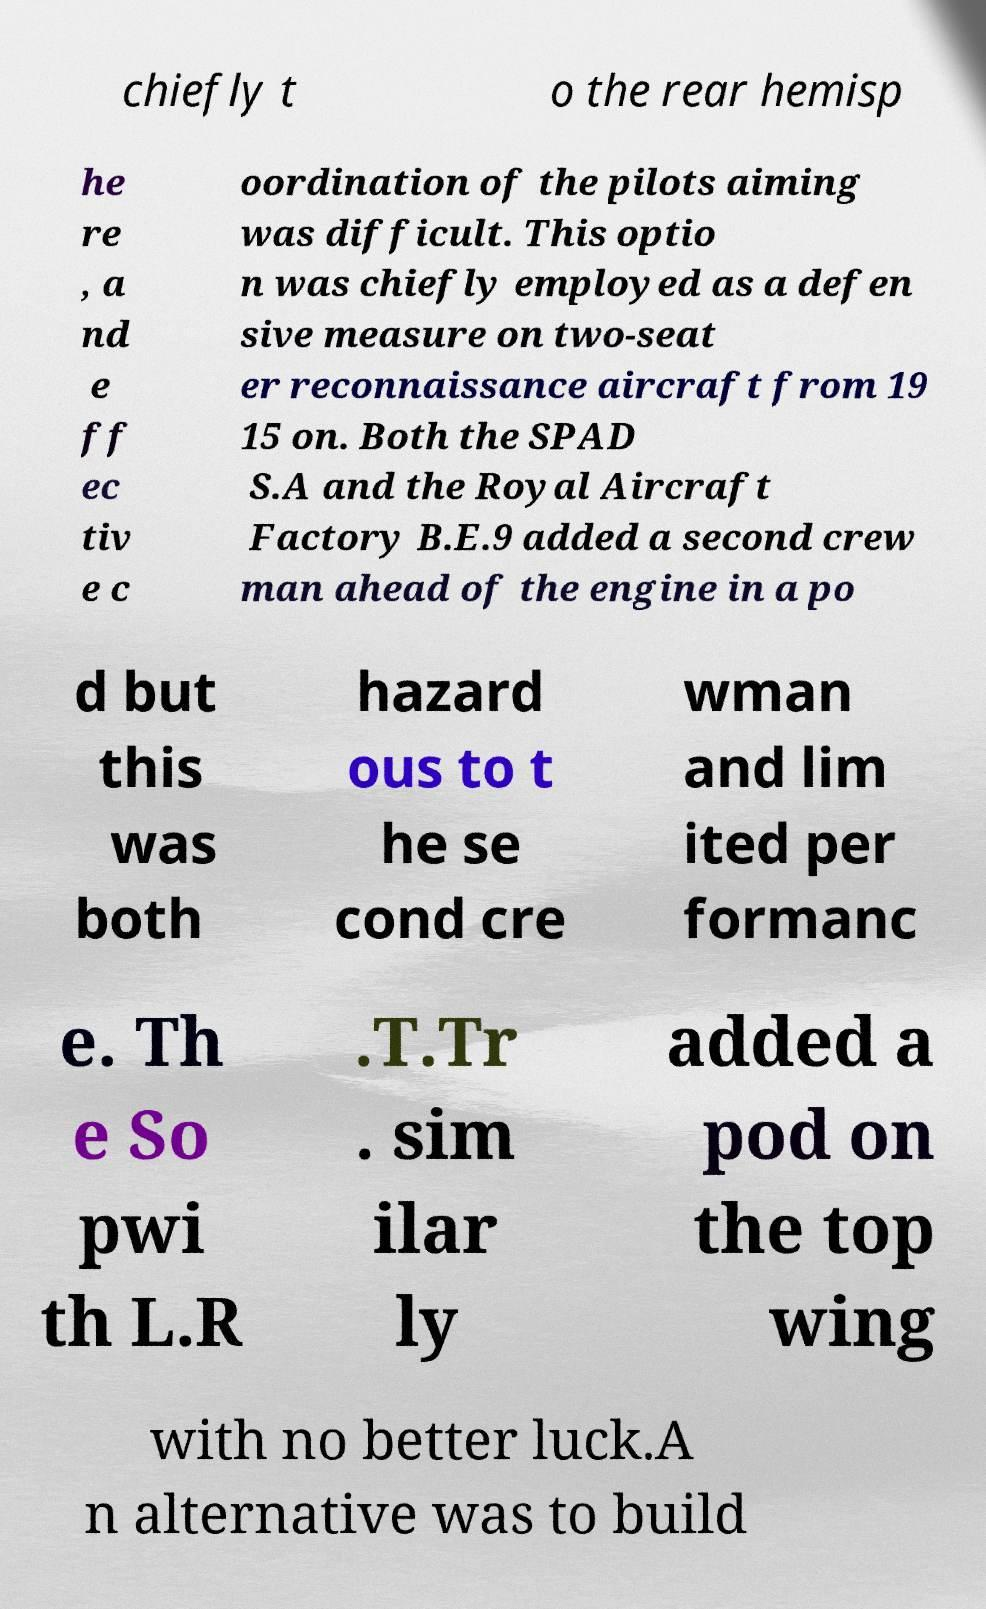I need the written content from this picture converted into text. Can you do that? chiefly t o the rear hemisp he re , a nd e ff ec tiv e c oordination of the pilots aiming was difficult. This optio n was chiefly employed as a defen sive measure on two-seat er reconnaissance aircraft from 19 15 on. Both the SPAD S.A and the Royal Aircraft Factory B.E.9 added a second crew man ahead of the engine in a po d but this was both hazard ous to t he se cond cre wman and lim ited per formanc e. Th e So pwi th L.R .T.Tr . sim ilar ly added a pod on the top wing with no better luck.A n alternative was to build 